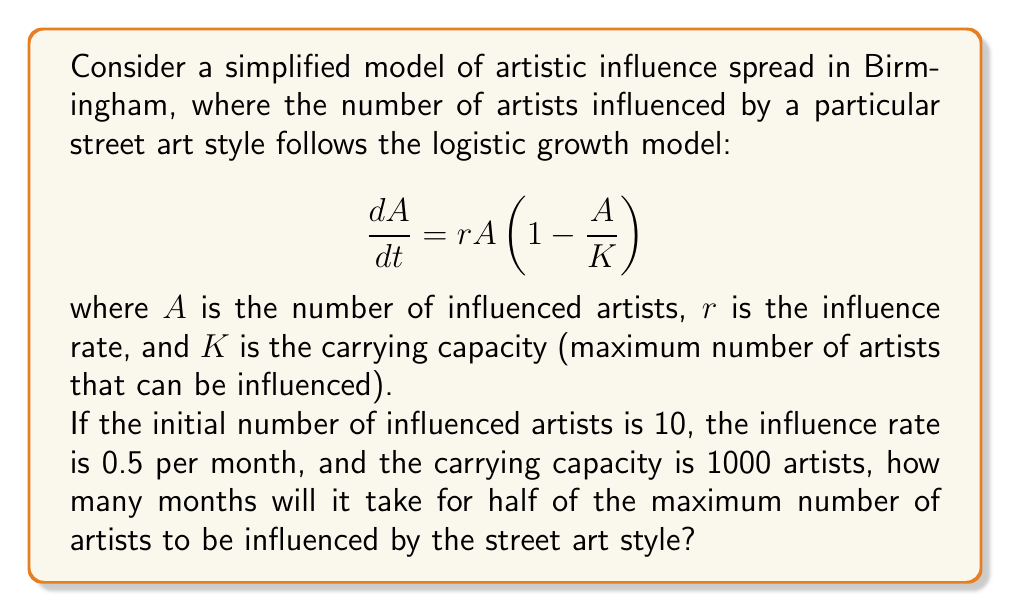Help me with this question. To solve this problem, we need to use the solution to the logistic differential equation and solve for time $t$ when $A = K/2$.

1) The solution to the logistic differential equation is:

   $$A(t) = \frac{K}{1 + \left(\frac{K}{A_0} - 1\right)e^{-rt}}$$

   where $A_0$ is the initial number of influenced artists.

2) We want to find $t$ when $A(t) = K/2$. Let's substitute our known values:
   $K = 1000$, $r = 0.5$, $A_0 = 10$

3) Set up the equation:

   $$\frac{1000}{2} = \frac{1000}{1 + \left(\frac{1000}{10} - 1\right)e^{-0.5t}}$$

4) Simplify:

   $$500 = \frac{1000}{1 + 99e^{-0.5t}}$$

5) Multiply both sides by $(1 + 99e^{-0.5t})$:

   $$500(1 + 99e^{-0.5t}) = 1000$$

6) Expand:

   $$500 + 49500e^{-0.5t} = 1000$$

7) Subtract 500 from both sides:

   $$49500e^{-0.5t} = 500$$

8) Divide both sides by 49500:

   $$e^{-0.5t} = \frac{1}{99}$$

9) Take the natural log of both sides:

   $$-0.5t = \ln\left(\frac{1}{99}\right) = -\ln(99)$$

10) Solve for $t$:

    $$t = \frac{2\ln(99)}{0.5} = 4\ln(99) \approx 18.37$$

Therefore, it will take approximately 18.37 months for half of the maximum number of artists to be influenced by the street art style.
Answer: Approximately 18.37 months 